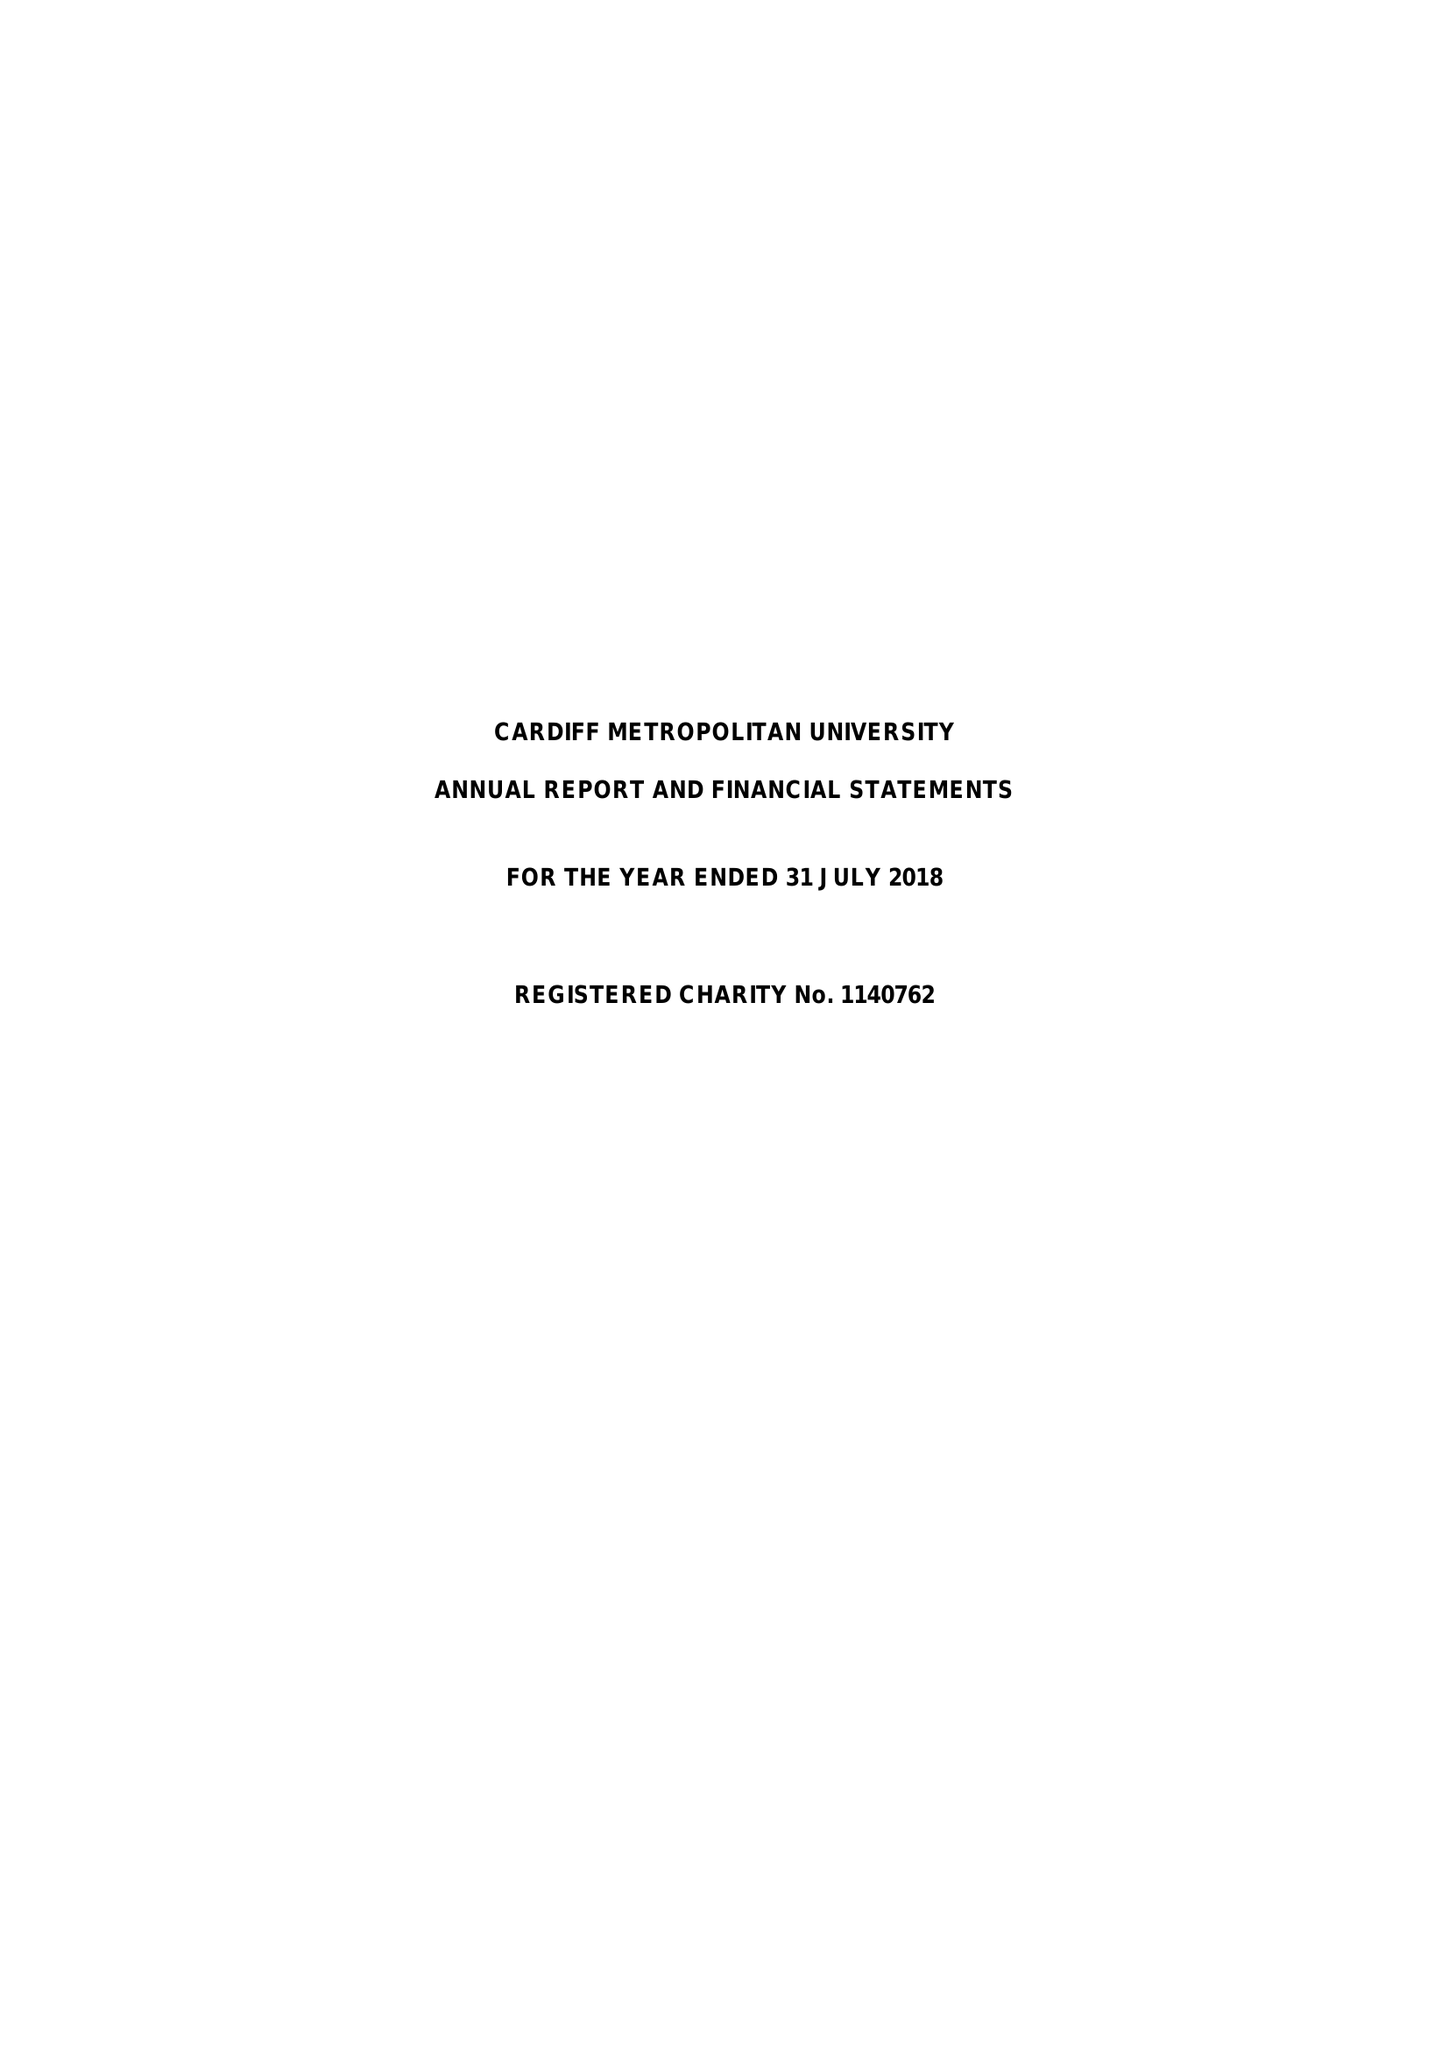What is the value for the address__postcode?
Answer the question using a single word or phrase. CF5 2YB 